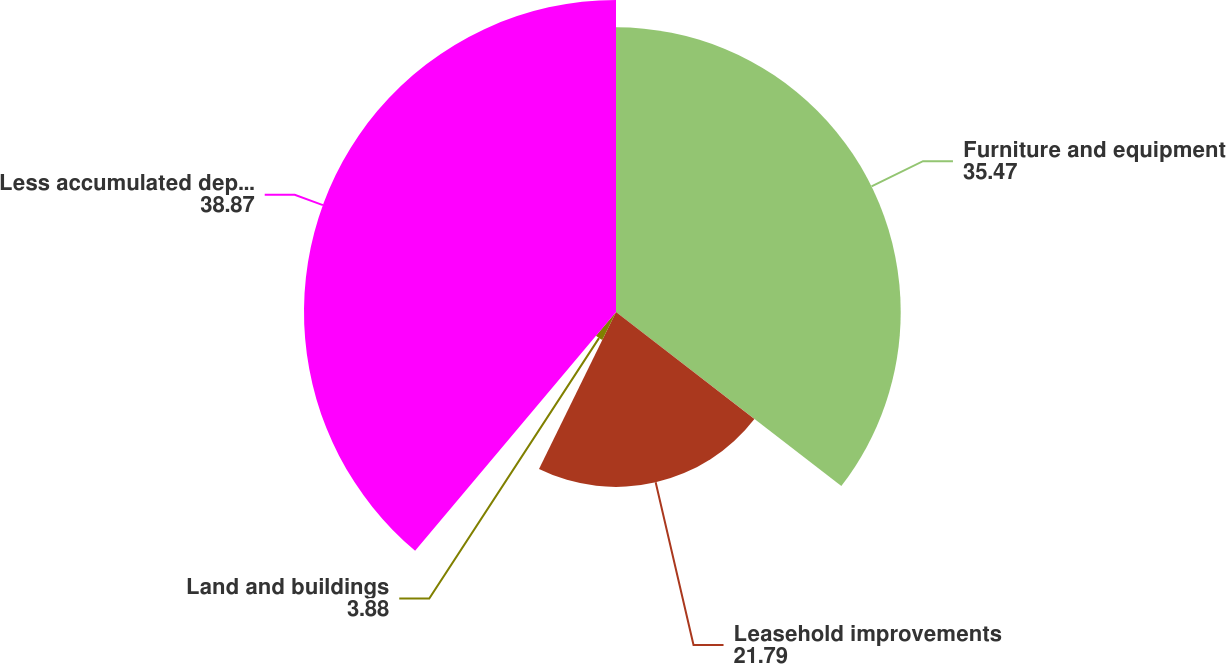<chart> <loc_0><loc_0><loc_500><loc_500><pie_chart><fcel>Furniture and equipment<fcel>Leasehold improvements<fcel>Land and buildings<fcel>Less accumulated depreciation<nl><fcel>35.47%<fcel>21.79%<fcel>3.88%<fcel>38.87%<nl></chart> 